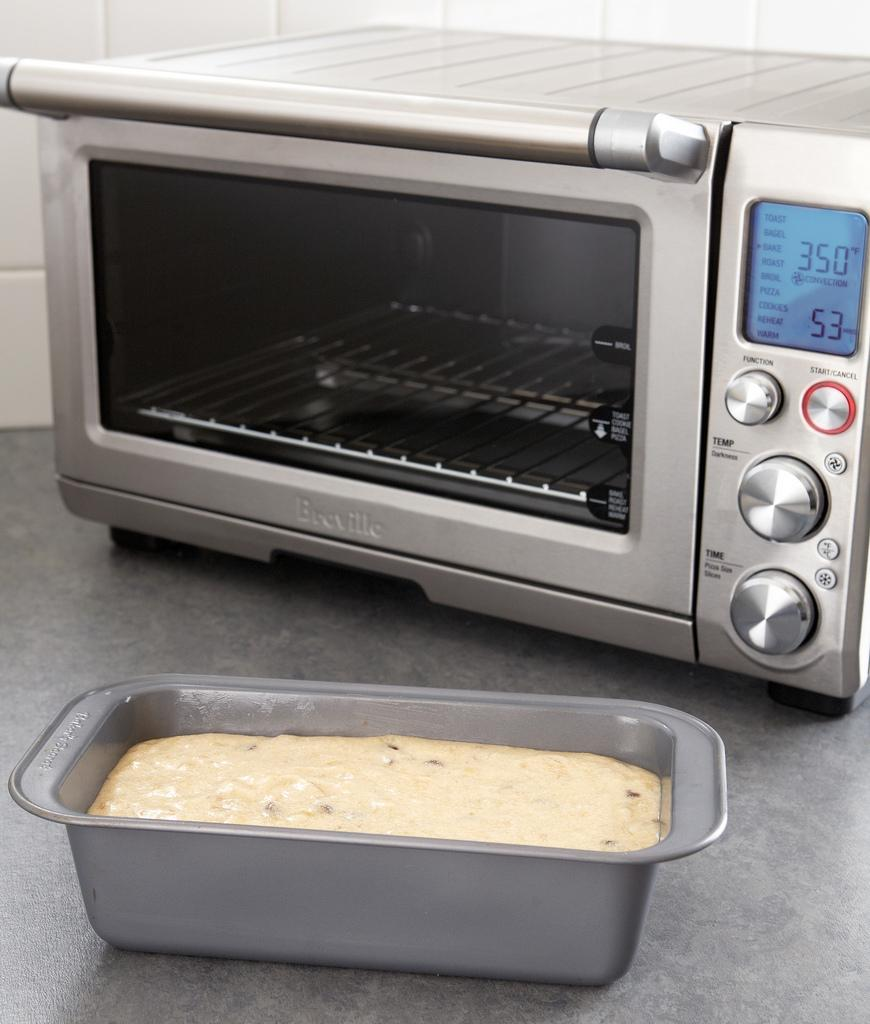<image>
Write a terse but informative summary of the picture. A pan of bread gets ready to be baked inside the Breville toaster oven set to 350 degrees 